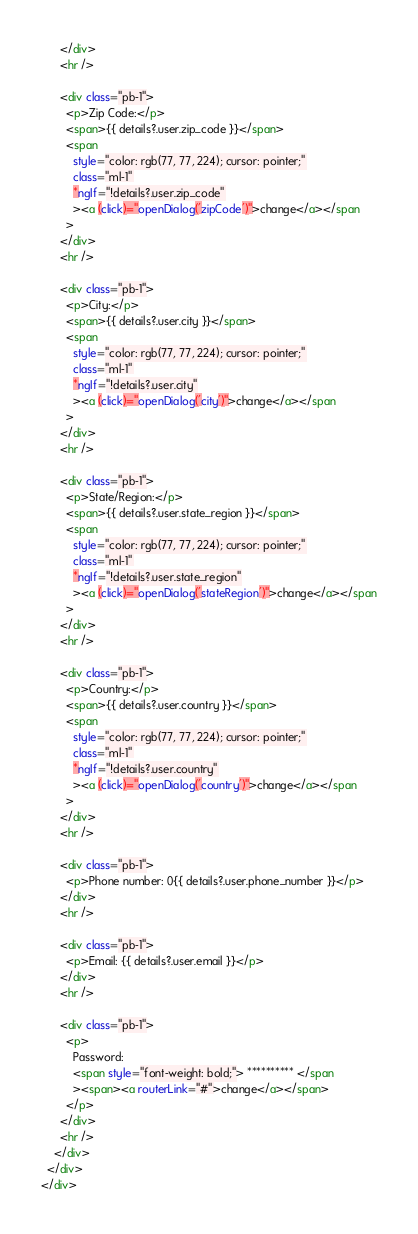Convert code to text. <code><loc_0><loc_0><loc_500><loc_500><_HTML_>      </div>
      <hr />

      <div class="pb-1">
        <p>Zip Code:</p>
        <span>{{ details?.user.zip_code }}</span>
        <span
          style="color: rgb(77, 77, 224); cursor: pointer;"
          class="ml-1"
          *ngIf="!details?.user.zip_code"
          ><a (click)="openDialog('zipCode')">change</a></span
        >
      </div>
      <hr />

      <div class="pb-1">
        <p>City:</p>
        <span>{{ details?.user.city }}</span>
        <span
          style="color: rgb(77, 77, 224); cursor: pointer;"
          class="ml-1"
          *ngIf="!details?.user.city"
          ><a (click)="openDialog('city')">change</a></span
        >
      </div>
      <hr />

      <div class="pb-1">
        <p>State/Region:</p>
        <span>{{ details?.user.state_region }}</span>
        <span
          style="color: rgb(77, 77, 224); cursor: pointer;"
          class="ml-1"
          *ngIf="!details?.user.state_region"
          ><a (click)="openDialog('stateRegion')">change</a></span
        >
      </div>
      <hr />

      <div class="pb-1">
        <p>Country:</p>
        <span>{{ details?.user.country }}</span>
        <span
          style="color: rgb(77, 77, 224); cursor: pointer;"
          class="ml-1"
          *ngIf="!details?.user.country"
          ><a (click)="openDialog('country')">change</a></span
        >
      </div>
      <hr />

      <div class="pb-1">
        <p>Phone number: 0{{ details?.user.phone_number }}</p>
      </div>
      <hr />

      <div class="pb-1">
        <p>Email: {{ details?.user.email }}</p>
      </div>
      <hr />

      <div class="pb-1">
        <p>
          Password:
          <span style="font-weight: bold;"> ********** </span
          ><span><a routerLink="#">change</a></span>
        </p>
      </div>
      <hr />
    </div>
  </div>
</div>
</code> 